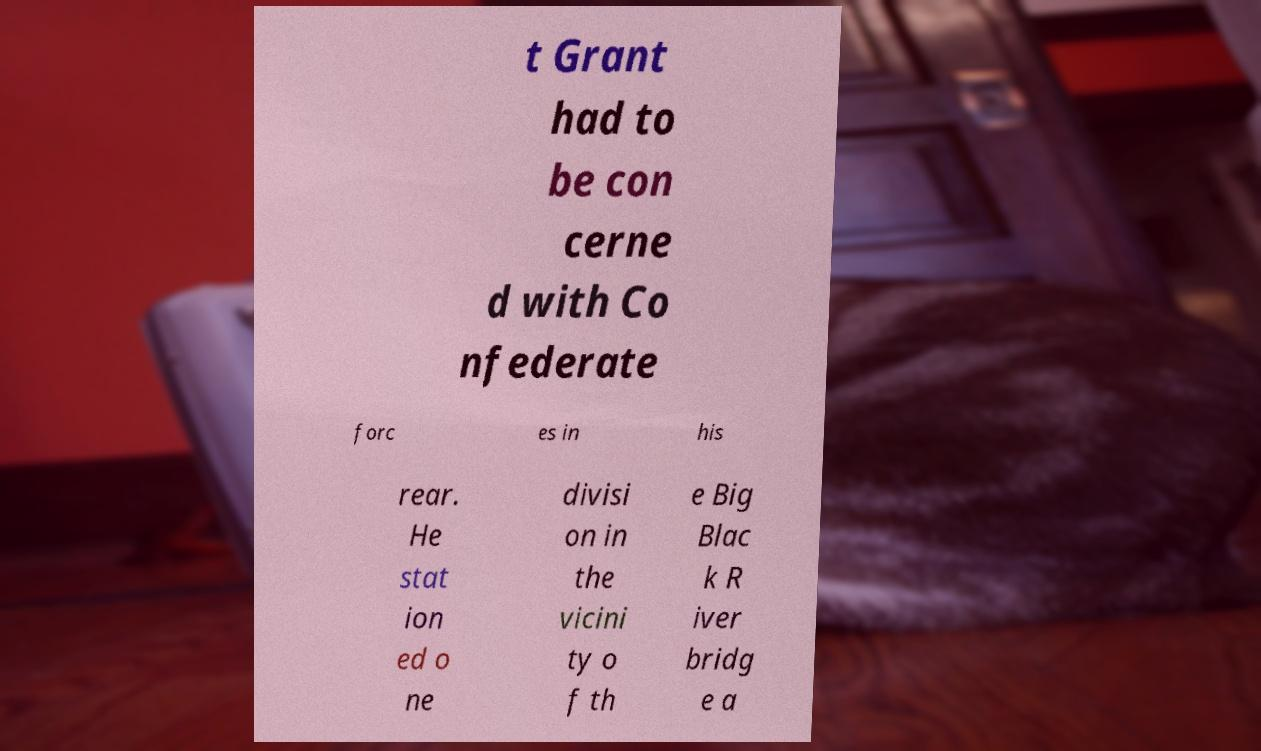Please identify and transcribe the text found in this image. t Grant had to be con cerne d with Co nfederate forc es in his rear. He stat ion ed o ne divisi on in the vicini ty o f th e Big Blac k R iver bridg e a 